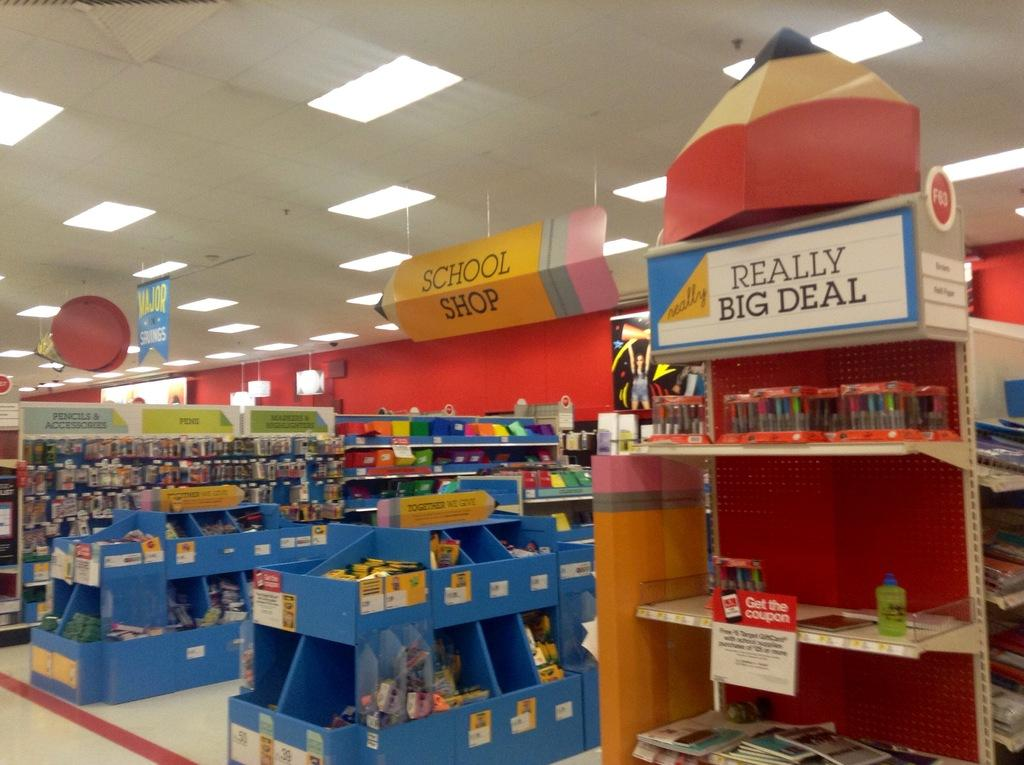<image>
Give a short and clear explanation of the subsequent image. a fake pencil at the top of a store that says school shop 